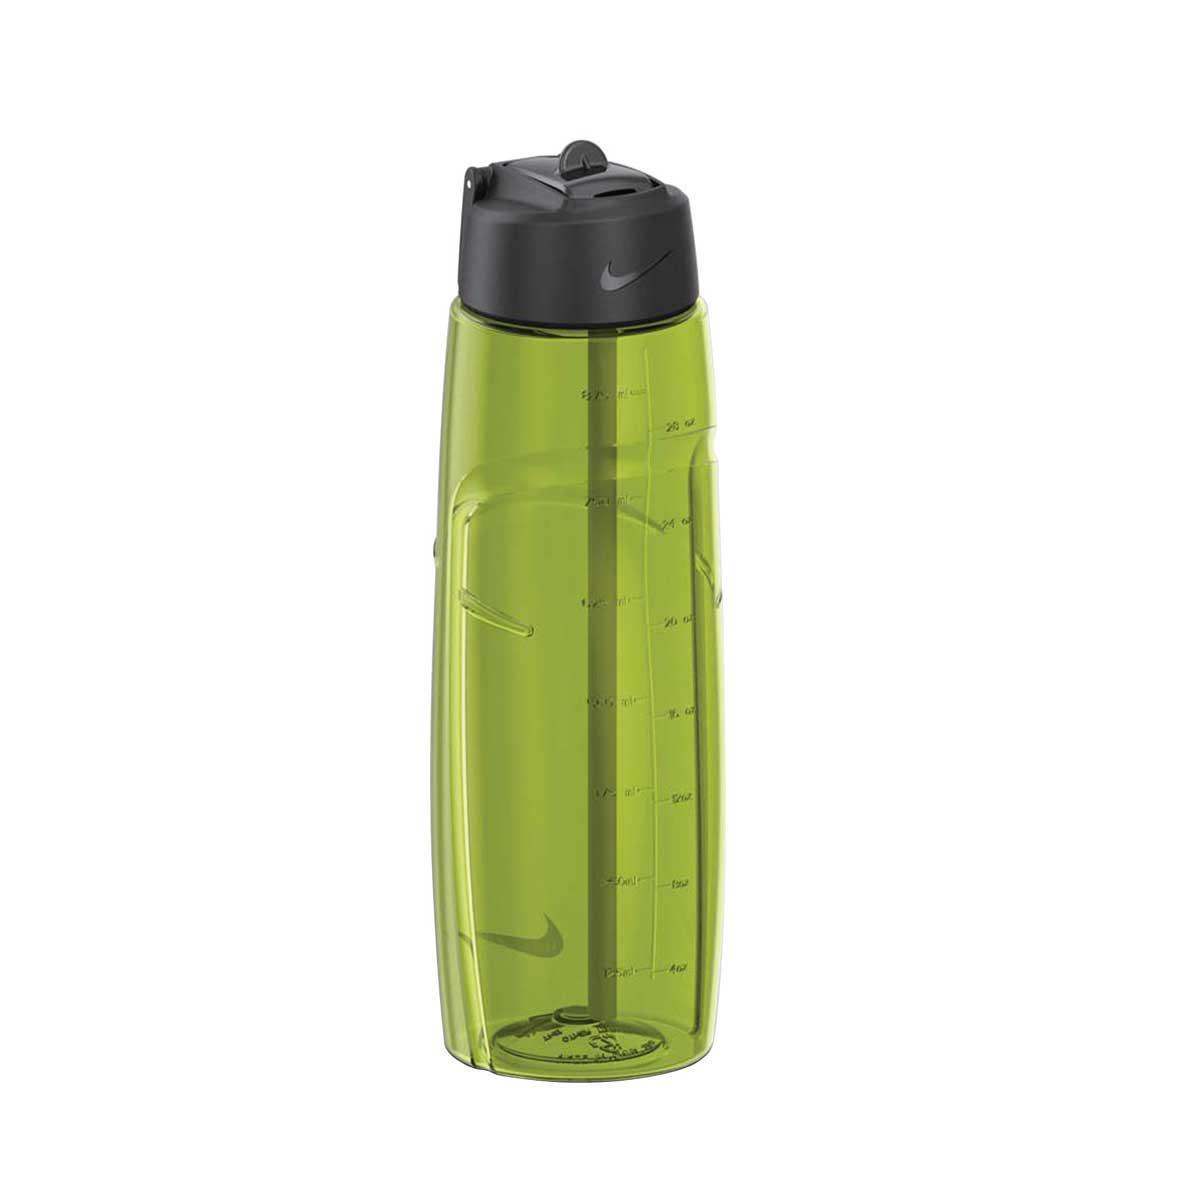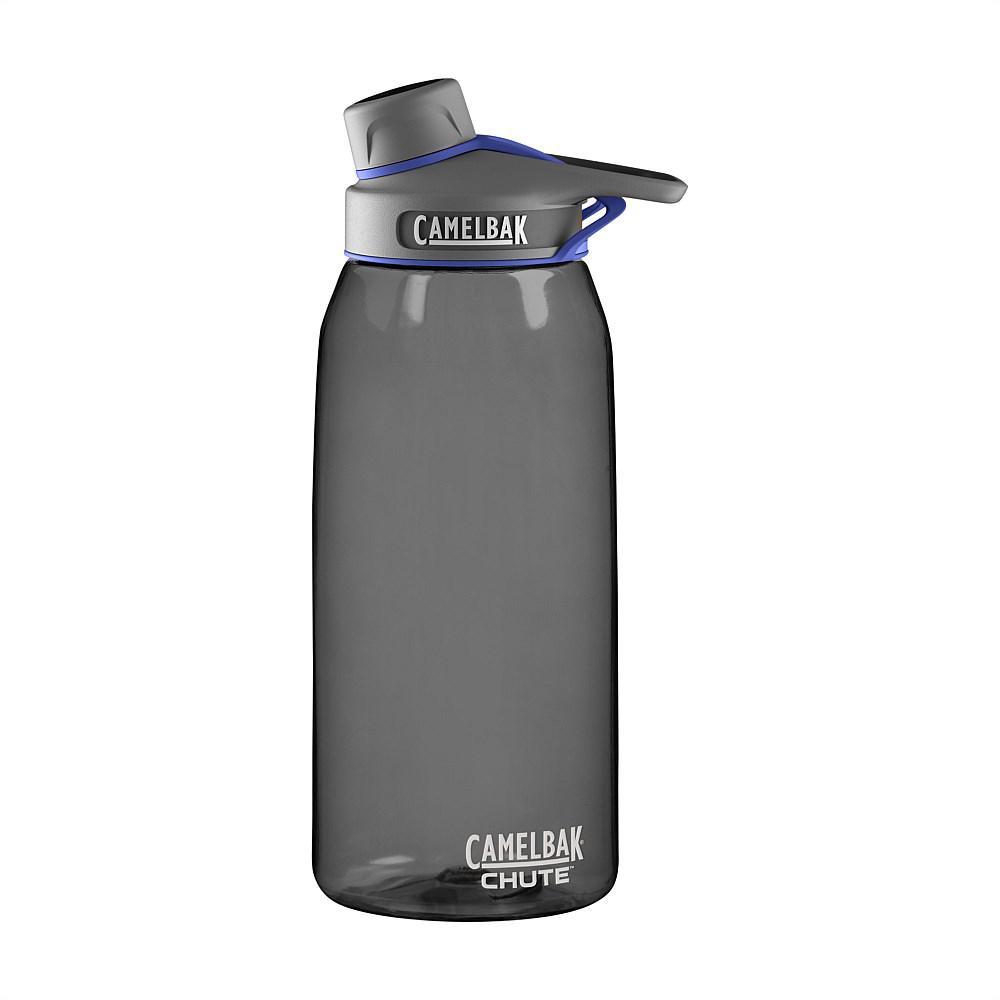The first image is the image on the left, the second image is the image on the right. For the images shown, is this caption "Both of the containers are made of a clear tinted material." true? Answer yes or no. Yes. The first image is the image on the left, the second image is the image on the right. Given the left and right images, does the statement "An image shows one water bottle with a black section and an indented shape." hold true? Answer yes or no. No. 